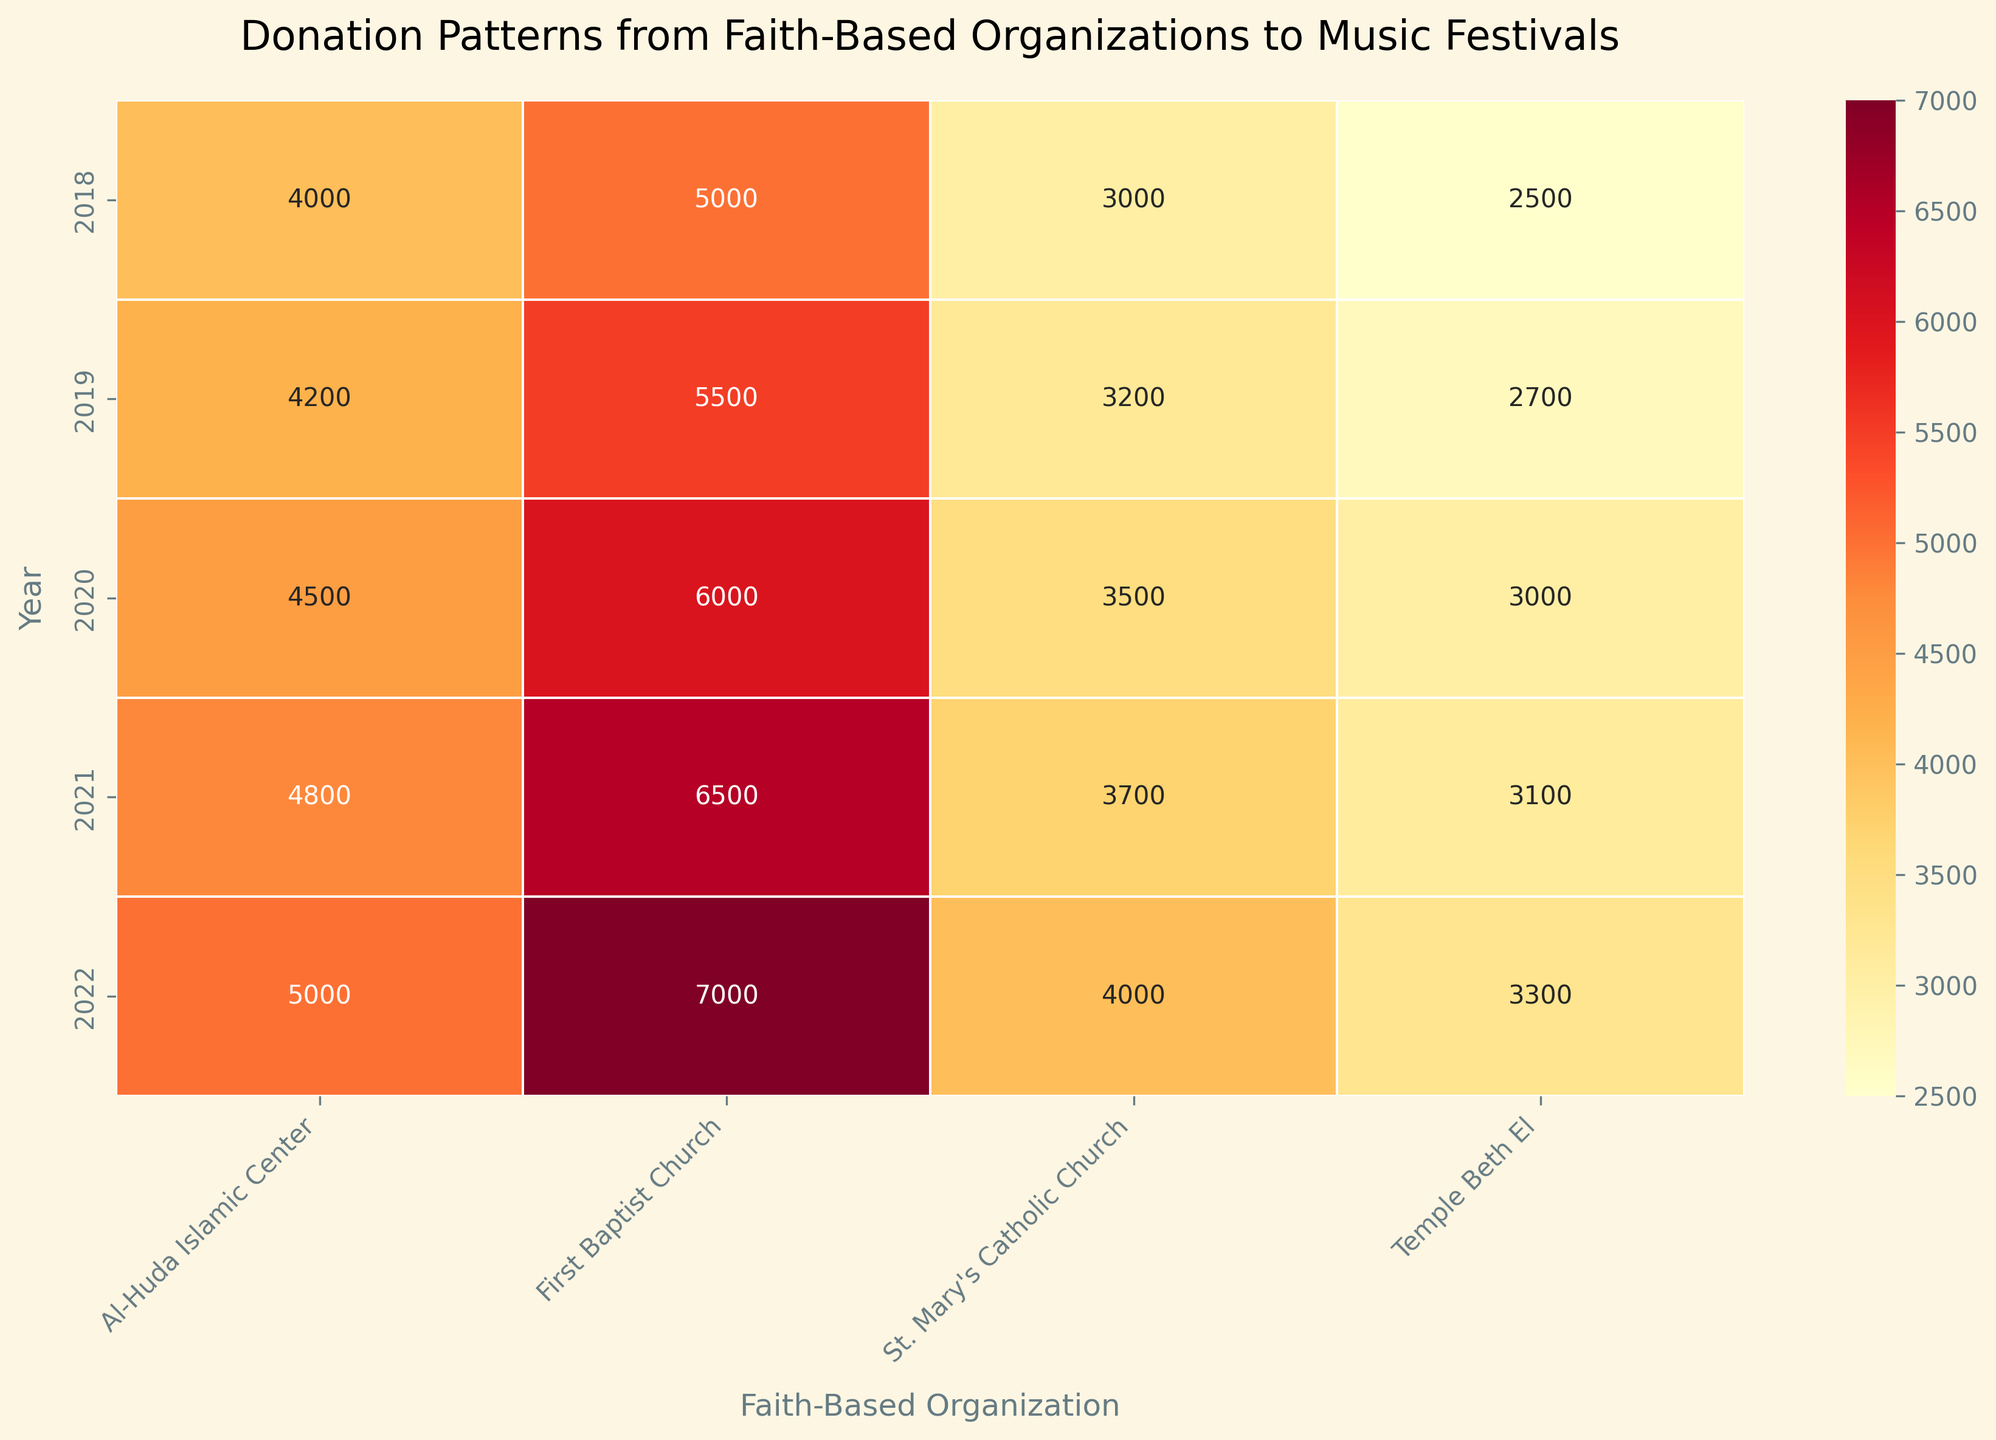Which year did the First Baptist Church make the highest donation? The heatmap shows donations from faith-based organizations each year. For the First Baptist Church, the highest value is in 2022, which is 7000.
Answer: 2022 What is the total donation amount from St. Mary's Catholic Church over the years? Sum the values for St. Mary's Catholic Church from 2018 to 2022. (3000 + 3200 + 3500 + 3700 + 4000) = 17400
Answer: 17400 Comparing 2018 and 2022, by how much did Temple Beth El's donation amount change? In 2018, Temple Beth El donated 2500 and in 2022, it donated 3300. The difference is 3300 - 2500 = 800.
Answer: 800 Which faith-based organization donated the least amount in 2021? Looking at the heatmap for 2021, Temple Beth El has the lowest donation value of 3100.
Answer: Temple Beth El Which organization showed a steady increase in donations each year from 2018 to 2022? By examining the heatmap values for each organization over the years, First Baptist Church, St. Mary's Catholic Church, Temple Beth El, and Al-Huda Islamic Center all show increasing donations annually.
Answer: All listed What was the average donation amount from Al-Huda Islamic Center over the years? Sum the donations from Al-Huda Islamic Center and divide by the number of years: (4000 + 4200 + 4500 + 4800 + 5000) / 5 = 4500
Answer: 4500 Which year received the highest total amount in donations from all faith-based organizations? Sum the total donations for each year: 2018: 14500; 2019: 15600; 2020: 17000; 2021: 18100; 2022: 19300. The highest is in 2022 with 19300.
Answer: 2022 By how much did St. Mary's Catholic Church's donation amount increase from 2018 to 2019? Subtract the 2018 donation of 3000 from the 2019 donation of 3200. (3200 - 3000) = 200
Answer: 200 In which year did Temple Beth El have the lowest donation? The heatmap shows the lowest value for Temple Beth El in 2018, which is 2500.
Answer: 2018 